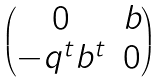Convert formula to latex. <formula><loc_0><loc_0><loc_500><loc_500>\begin{pmatrix} 0 & b \\ - q ^ { t } b ^ { t } & 0 \end{pmatrix}</formula> 